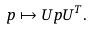<formula> <loc_0><loc_0><loc_500><loc_500>& p \mapsto U p U ^ { T } .</formula> 